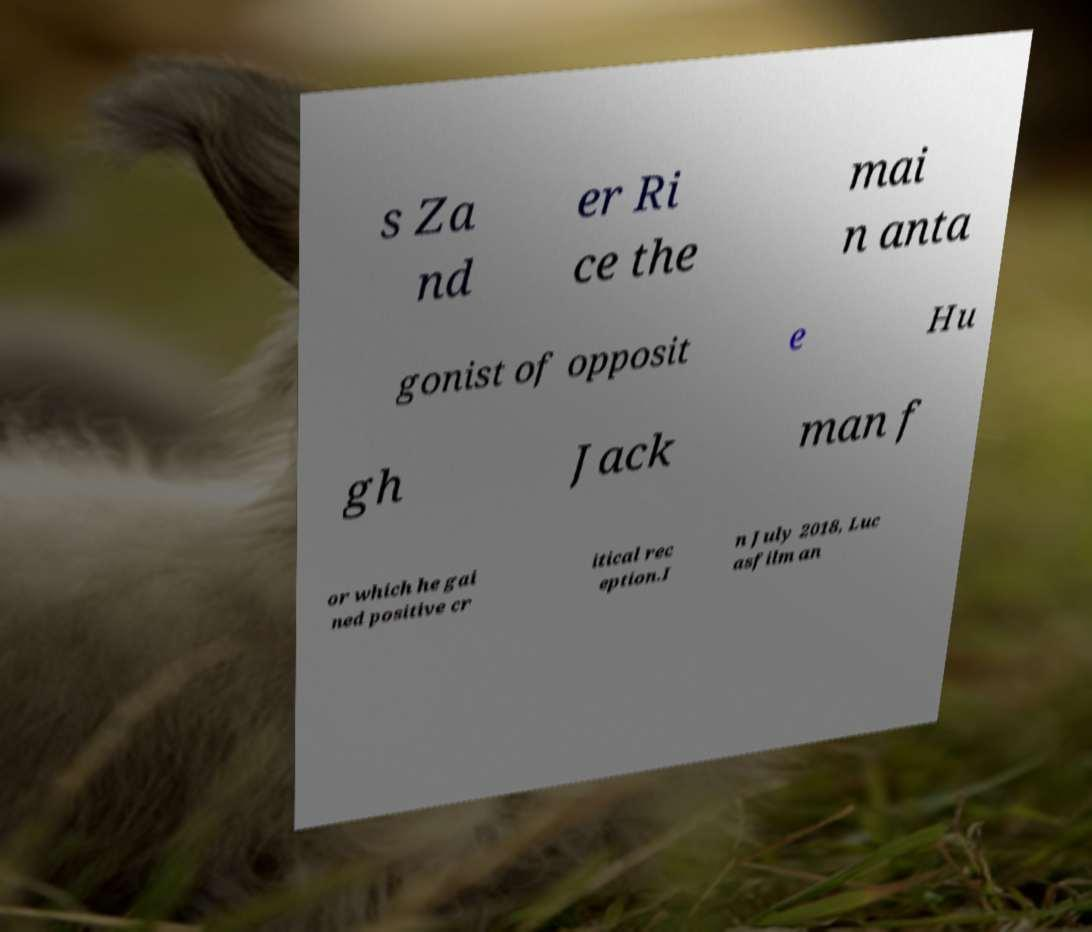Please identify and transcribe the text found in this image. s Za nd er Ri ce the mai n anta gonist of opposit e Hu gh Jack man f or which he gai ned positive cr itical rec eption.I n July 2018, Luc asfilm an 